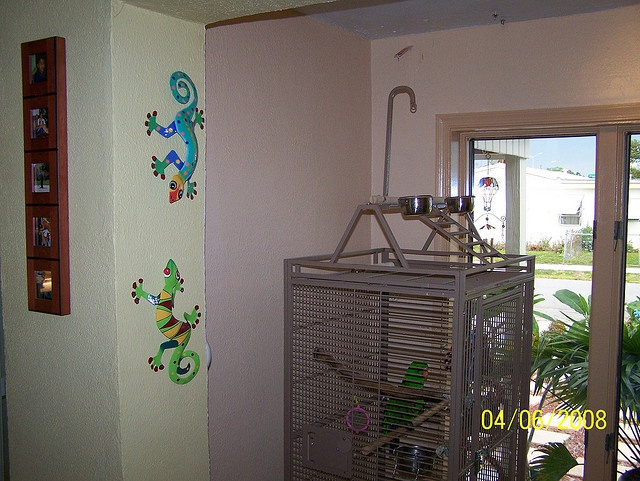Describe the objects in this image and their specific colors. I can see potted plant in darkgreen, black, white, and gray tones and bird in darkgreen, black, and gray tones in this image. 